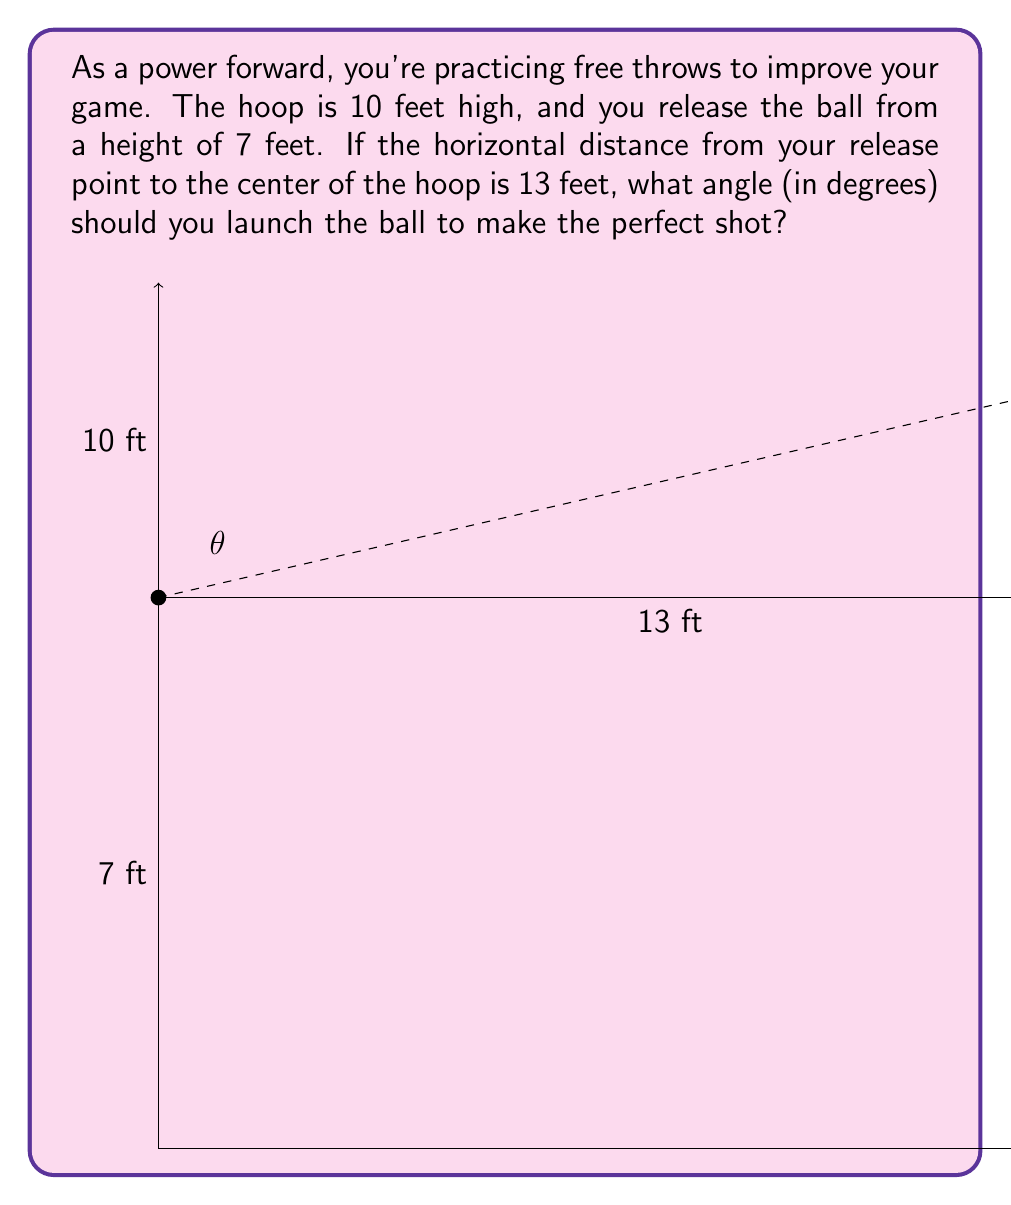Help me with this question. Let's approach this step-by-step:

1) First, we need to identify the right triangle formed by the ball's trajectory. The base of this triangle is 13 feet (horizontal distance), and the height is the difference between the hoop height and release height: 10 ft - 7 ft = 3 ft.

2) We can use the tangent function to find the angle. In a right triangle, tangent of an angle is the opposite side divided by the adjacent side.

3) Let $\theta$ be the angle we're looking for. Then:

   $$\tan(\theta) = \frac{\text{opposite}}{\text{adjacent}} = \frac{3}{13}$$

4) To find $\theta$, we need to use the inverse tangent (arctan or $\tan^{-1}$):

   $$\theta = \tan^{-1}(\frac{3}{13})$$

5) Using a calculator or computer:

   $$\theta \approx 13.0045^\circ$$

6) Rounding to the nearest tenth of a degree:

   $$\theta \approx 13.0^\circ$$

Therefore, you should launch the ball at an angle of approximately 13.0° above the horizontal to make the perfect shot.
Answer: $13.0^\circ$ 